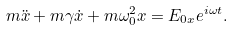Convert formula to latex. <formula><loc_0><loc_0><loc_500><loc_500>m \ddot { x } + m \gamma \dot { x } + m \omega _ { 0 } ^ { 2 } x = E _ { 0 x } e ^ { i \omega t } .</formula> 